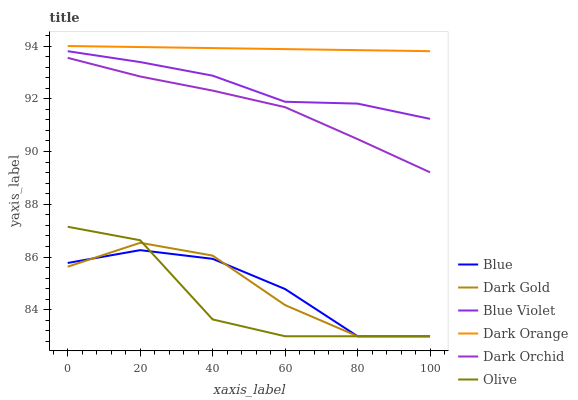Does Dark Gold have the minimum area under the curve?
Answer yes or no. No. Does Dark Gold have the maximum area under the curve?
Answer yes or no. No. Is Dark Gold the smoothest?
Answer yes or no. No. Is Dark Gold the roughest?
Answer yes or no. No. Does Dark Orange have the lowest value?
Answer yes or no. No. Does Dark Gold have the highest value?
Answer yes or no. No. Is Dark Orchid less than Dark Orange?
Answer yes or no. Yes. Is Blue Violet greater than Olive?
Answer yes or no. Yes. Does Dark Orchid intersect Dark Orange?
Answer yes or no. No. 